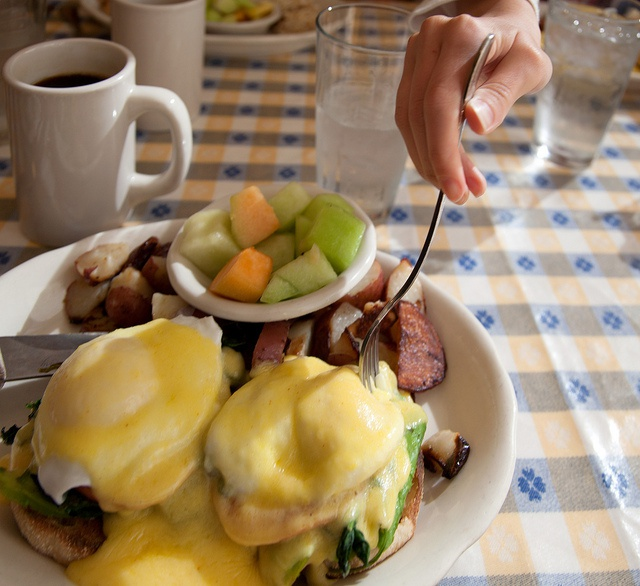Describe the objects in this image and their specific colors. I can see dining table in maroon, gray, lightgray, tan, and darkgray tones, cup in maroon and gray tones, bowl in maroon, tan, olive, and gray tones, people in maroon, brown, and tan tones, and cup in maroon, gray, and brown tones in this image. 